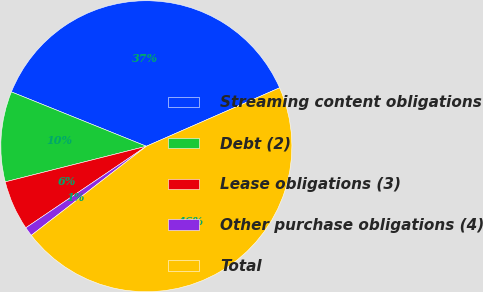<chart> <loc_0><loc_0><loc_500><loc_500><pie_chart><fcel>Streaming content obligations<fcel>Debt (2)<fcel>Lease obligations (3)<fcel>Other purchase obligations (4)<fcel>Total<nl><fcel>37.32%<fcel>10.03%<fcel>5.53%<fcel>1.02%<fcel>46.09%<nl></chart> 